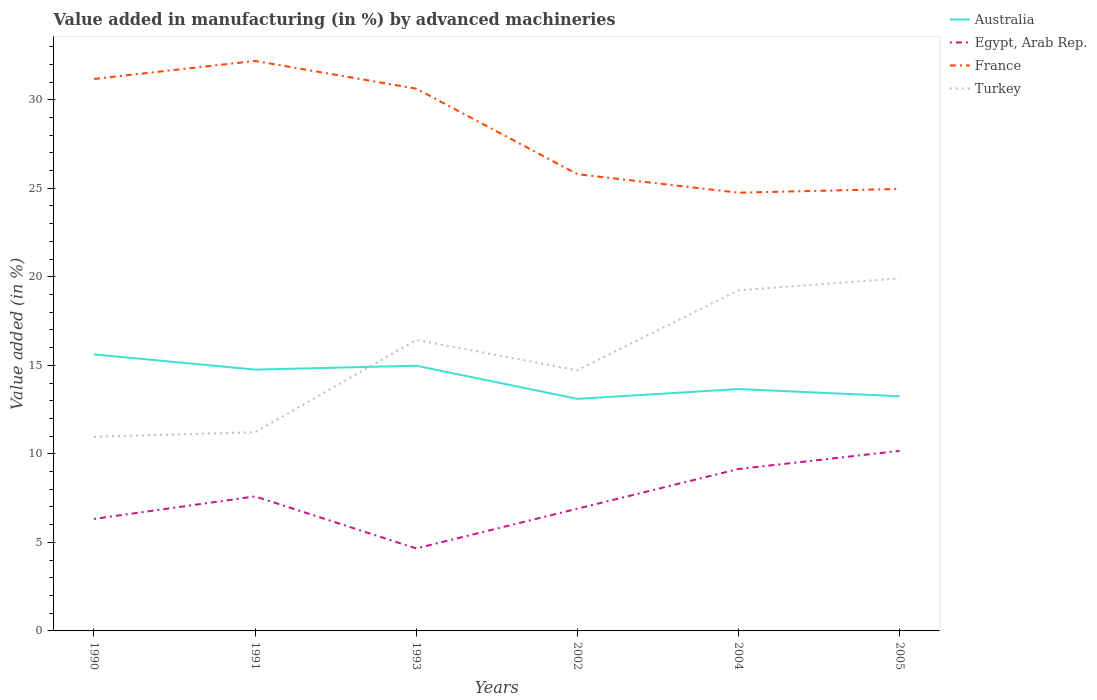Is the number of lines equal to the number of legend labels?
Offer a very short reply. Yes. Across all years, what is the maximum percentage of value added in manufacturing by advanced machineries in Egypt, Arab Rep.?
Offer a terse response. 4.66. In which year was the percentage of value added in manufacturing by advanced machineries in Egypt, Arab Rep. maximum?
Keep it short and to the point. 1993. What is the total percentage of value added in manufacturing by advanced machineries in Australia in the graph?
Keep it short and to the point. 0.41. What is the difference between the highest and the second highest percentage of value added in manufacturing by advanced machineries in Turkey?
Your answer should be very brief. 8.95. Are the values on the major ticks of Y-axis written in scientific E-notation?
Provide a succinct answer. No. Does the graph contain any zero values?
Your answer should be compact. No. Does the graph contain grids?
Keep it short and to the point. No. Where does the legend appear in the graph?
Provide a succinct answer. Top right. How many legend labels are there?
Provide a short and direct response. 4. What is the title of the graph?
Provide a short and direct response. Value added in manufacturing (in %) by advanced machineries. What is the label or title of the X-axis?
Ensure brevity in your answer.  Years. What is the label or title of the Y-axis?
Offer a terse response. Value added (in %). What is the Value added (in %) of Australia in 1990?
Your answer should be very brief. 15.62. What is the Value added (in %) of Egypt, Arab Rep. in 1990?
Ensure brevity in your answer.  6.33. What is the Value added (in %) of France in 1990?
Ensure brevity in your answer.  31.17. What is the Value added (in %) in Turkey in 1990?
Provide a short and direct response. 10.97. What is the Value added (in %) of Australia in 1991?
Provide a short and direct response. 14.76. What is the Value added (in %) in Egypt, Arab Rep. in 1991?
Provide a succinct answer. 7.6. What is the Value added (in %) of France in 1991?
Give a very brief answer. 32.19. What is the Value added (in %) in Turkey in 1991?
Your response must be concise. 11.22. What is the Value added (in %) of Australia in 1993?
Give a very brief answer. 14.98. What is the Value added (in %) of Egypt, Arab Rep. in 1993?
Offer a terse response. 4.66. What is the Value added (in %) in France in 1993?
Give a very brief answer. 30.63. What is the Value added (in %) of Turkey in 1993?
Keep it short and to the point. 16.44. What is the Value added (in %) of Australia in 2002?
Give a very brief answer. 13.11. What is the Value added (in %) in Egypt, Arab Rep. in 2002?
Your answer should be compact. 6.9. What is the Value added (in %) of France in 2002?
Your response must be concise. 25.8. What is the Value added (in %) of Turkey in 2002?
Your answer should be very brief. 14.72. What is the Value added (in %) in Australia in 2004?
Your response must be concise. 13.66. What is the Value added (in %) of Egypt, Arab Rep. in 2004?
Ensure brevity in your answer.  9.14. What is the Value added (in %) of France in 2004?
Your answer should be compact. 24.75. What is the Value added (in %) in Turkey in 2004?
Provide a short and direct response. 19.24. What is the Value added (in %) in Australia in 2005?
Your answer should be compact. 13.25. What is the Value added (in %) of Egypt, Arab Rep. in 2005?
Keep it short and to the point. 10.17. What is the Value added (in %) of France in 2005?
Your answer should be very brief. 24.96. What is the Value added (in %) of Turkey in 2005?
Your answer should be very brief. 19.91. Across all years, what is the maximum Value added (in %) in Australia?
Offer a terse response. 15.62. Across all years, what is the maximum Value added (in %) in Egypt, Arab Rep.?
Provide a short and direct response. 10.17. Across all years, what is the maximum Value added (in %) of France?
Offer a very short reply. 32.19. Across all years, what is the maximum Value added (in %) of Turkey?
Give a very brief answer. 19.91. Across all years, what is the minimum Value added (in %) of Australia?
Keep it short and to the point. 13.11. Across all years, what is the minimum Value added (in %) of Egypt, Arab Rep.?
Offer a terse response. 4.66. Across all years, what is the minimum Value added (in %) of France?
Your answer should be compact. 24.75. Across all years, what is the minimum Value added (in %) in Turkey?
Offer a very short reply. 10.97. What is the total Value added (in %) in Australia in the graph?
Keep it short and to the point. 85.37. What is the total Value added (in %) in Egypt, Arab Rep. in the graph?
Make the answer very short. 44.8. What is the total Value added (in %) of France in the graph?
Keep it short and to the point. 169.5. What is the total Value added (in %) of Turkey in the graph?
Ensure brevity in your answer.  92.49. What is the difference between the Value added (in %) in Australia in 1990 and that in 1991?
Keep it short and to the point. 0.86. What is the difference between the Value added (in %) in Egypt, Arab Rep. in 1990 and that in 1991?
Make the answer very short. -1.27. What is the difference between the Value added (in %) of France in 1990 and that in 1991?
Offer a very short reply. -1.02. What is the difference between the Value added (in %) of Turkey in 1990 and that in 1991?
Your response must be concise. -0.26. What is the difference between the Value added (in %) of Australia in 1990 and that in 1993?
Your answer should be very brief. 0.64. What is the difference between the Value added (in %) in Egypt, Arab Rep. in 1990 and that in 1993?
Give a very brief answer. 1.67. What is the difference between the Value added (in %) of France in 1990 and that in 1993?
Make the answer very short. 0.55. What is the difference between the Value added (in %) in Turkey in 1990 and that in 1993?
Make the answer very short. -5.47. What is the difference between the Value added (in %) in Australia in 1990 and that in 2002?
Keep it short and to the point. 2.51. What is the difference between the Value added (in %) of Egypt, Arab Rep. in 1990 and that in 2002?
Your answer should be compact. -0.58. What is the difference between the Value added (in %) of France in 1990 and that in 2002?
Provide a succinct answer. 5.38. What is the difference between the Value added (in %) in Turkey in 1990 and that in 2002?
Make the answer very short. -3.75. What is the difference between the Value added (in %) of Australia in 1990 and that in 2004?
Offer a very short reply. 1.96. What is the difference between the Value added (in %) in Egypt, Arab Rep. in 1990 and that in 2004?
Give a very brief answer. -2.82. What is the difference between the Value added (in %) of France in 1990 and that in 2004?
Offer a very short reply. 6.42. What is the difference between the Value added (in %) in Turkey in 1990 and that in 2004?
Your answer should be compact. -8.27. What is the difference between the Value added (in %) of Australia in 1990 and that in 2005?
Give a very brief answer. 2.36. What is the difference between the Value added (in %) in Egypt, Arab Rep. in 1990 and that in 2005?
Your answer should be compact. -3.84. What is the difference between the Value added (in %) of France in 1990 and that in 2005?
Ensure brevity in your answer.  6.21. What is the difference between the Value added (in %) of Turkey in 1990 and that in 2005?
Your response must be concise. -8.95. What is the difference between the Value added (in %) in Australia in 1991 and that in 1993?
Your answer should be very brief. -0.22. What is the difference between the Value added (in %) in Egypt, Arab Rep. in 1991 and that in 1993?
Give a very brief answer. 2.94. What is the difference between the Value added (in %) of France in 1991 and that in 1993?
Make the answer very short. 1.56. What is the difference between the Value added (in %) of Turkey in 1991 and that in 1993?
Make the answer very short. -5.21. What is the difference between the Value added (in %) of Australia in 1991 and that in 2002?
Your answer should be compact. 1.65. What is the difference between the Value added (in %) in Egypt, Arab Rep. in 1991 and that in 2002?
Give a very brief answer. 0.69. What is the difference between the Value added (in %) of France in 1991 and that in 2002?
Ensure brevity in your answer.  6.4. What is the difference between the Value added (in %) in Turkey in 1991 and that in 2002?
Keep it short and to the point. -3.5. What is the difference between the Value added (in %) of Australia in 1991 and that in 2004?
Your answer should be very brief. 1.1. What is the difference between the Value added (in %) of Egypt, Arab Rep. in 1991 and that in 2004?
Offer a terse response. -1.55. What is the difference between the Value added (in %) of France in 1991 and that in 2004?
Provide a succinct answer. 7.44. What is the difference between the Value added (in %) in Turkey in 1991 and that in 2004?
Your answer should be compact. -8.02. What is the difference between the Value added (in %) in Australia in 1991 and that in 2005?
Your answer should be compact. 1.51. What is the difference between the Value added (in %) in Egypt, Arab Rep. in 1991 and that in 2005?
Offer a terse response. -2.57. What is the difference between the Value added (in %) in France in 1991 and that in 2005?
Your answer should be very brief. 7.23. What is the difference between the Value added (in %) of Turkey in 1991 and that in 2005?
Make the answer very short. -8.69. What is the difference between the Value added (in %) in Australia in 1993 and that in 2002?
Offer a terse response. 1.87. What is the difference between the Value added (in %) of Egypt, Arab Rep. in 1993 and that in 2002?
Provide a succinct answer. -2.25. What is the difference between the Value added (in %) of France in 1993 and that in 2002?
Keep it short and to the point. 4.83. What is the difference between the Value added (in %) in Turkey in 1993 and that in 2002?
Your answer should be compact. 1.72. What is the difference between the Value added (in %) in Australia in 1993 and that in 2004?
Offer a very short reply. 1.32. What is the difference between the Value added (in %) of Egypt, Arab Rep. in 1993 and that in 2004?
Ensure brevity in your answer.  -4.49. What is the difference between the Value added (in %) of France in 1993 and that in 2004?
Offer a very short reply. 5.88. What is the difference between the Value added (in %) in Turkey in 1993 and that in 2004?
Make the answer very short. -2.8. What is the difference between the Value added (in %) of Australia in 1993 and that in 2005?
Offer a very short reply. 1.72. What is the difference between the Value added (in %) of Egypt, Arab Rep. in 1993 and that in 2005?
Offer a terse response. -5.51. What is the difference between the Value added (in %) of France in 1993 and that in 2005?
Your answer should be very brief. 5.66. What is the difference between the Value added (in %) in Turkey in 1993 and that in 2005?
Provide a succinct answer. -3.48. What is the difference between the Value added (in %) in Australia in 2002 and that in 2004?
Ensure brevity in your answer.  -0.55. What is the difference between the Value added (in %) of Egypt, Arab Rep. in 2002 and that in 2004?
Your answer should be very brief. -2.24. What is the difference between the Value added (in %) of France in 2002 and that in 2004?
Your response must be concise. 1.04. What is the difference between the Value added (in %) in Turkey in 2002 and that in 2004?
Keep it short and to the point. -4.52. What is the difference between the Value added (in %) in Australia in 2002 and that in 2005?
Make the answer very short. -0.15. What is the difference between the Value added (in %) of Egypt, Arab Rep. in 2002 and that in 2005?
Offer a very short reply. -3.26. What is the difference between the Value added (in %) in France in 2002 and that in 2005?
Your answer should be very brief. 0.83. What is the difference between the Value added (in %) of Turkey in 2002 and that in 2005?
Offer a very short reply. -5.19. What is the difference between the Value added (in %) in Australia in 2004 and that in 2005?
Your answer should be very brief. 0.41. What is the difference between the Value added (in %) of Egypt, Arab Rep. in 2004 and that in 2005?
Your response must be concise. -1.02. What is the difference between the Value added (in %) of France in 2004 and that in 2005?
Offer a terse response. -0.21. What is the difference between the Value added (in %) of Turkey in 2004 and that in 2005?
Your answer should be very brief. -0.67. What is the difference between the Value added (in %) in Australia in 1990 and the Value added (in %) in Egypt, Arab Rep. in 1991?
Your answer should be compact. 8.02. What is the difference between the Value added (in %) in Australia in 1990 and the Value added (in %) in France in 1991?
Your answer should be very brief. -16.57. What is the difference between the Value added (in %) in Australia in 1990 and the Value added (in %) in Turkey in 1991?
Your answer should be compact. 4.4. What is the difference between the Value added (in %) in Egypt, Arab Rep. in 1990 and the Value added (in %) in France in 1991?
Give a very brief answer. -25.86. What is the difference between the Value added (in %) of Egypt, Arab Rep. in 1990 and the Value added (in %) of Turkey in 1991?
Offer a very short reply. -4.9. What is the difference between the Value added (in %) of France in 1990 and the Value added (in %) of Turkey in 1991?
Provide a short and direct response. 19.95. What is the difference between the Value added (in %) of Australia in 1990 and the Value added (in %) of Egypt, Arab Rep. in 1993?
Your response must be concise. 10.96. What is the difference between the Value added (in %) in Australia in 1990 and the Value added (in %) in France in 1993?
Offer a very short reply. -15.01. What is the difference between the Value added (in %) in Australia in 1990 and the Value added (in %) in Turkey in 1993?
Provide a short and direct response. -0.82. What is the difference between the Value added (in %) of Egypt, Arab Rep. in 1990 and the Value added (in %) of France in 1993?
Ensure brevity in your answer.  -24.3. What is the difference between the Value added (in %) of Egypt, Arab Rep. in 1990 and the Value added (in %) of Turkey in 1993?
Your response must be concise. -10.11. What is the difference between the Value added (in %) in France in 1990 and the Value added (in %) in Turkey in 1993?
Keep it short and to the point. 14.74. What is the difference between the Value added (in %) of Australia in 1990 and the Value added (in %) of Egypt, Arab Rep. in 2002?
Give a very brief answer. 8.71. What is the difference between the Value added (in %) in Australia in 1990 and the Value added (in %) in France in 2002?
Make the answer very short. -10.18. What is the difference between the Value added (in %) in Australia in 1990 and the Value added (in %) in Turkey in 2002?
Offer a very short reply. 0.9. What is the difference between the Value added (in %) of Egypt, Arab Rep. in 1990 and the Value added (in %) of France in 2002?
Ensure brevity in your answer.  -19.47. What is the difference between the Value added (in %) in Egypt, Arab Rep. in 1990 and the Value added (in %) in Turkey in 2002?
Ensure brevity in your answer.  -8.39. What is the difference between the Value added (in %) in France in 1990 and the Value added (in %) in Turkey in 2002?
Provide a short and direct response. 16.45. What is the difference between the Value added (in %) of Australia in 1990 and the Value added (in %) of Egypt, Arab Rep. in 2004?
Provide a succinct answer. 6.47. What is the difference between the Value added (in %) in Australia in 1990 and the Value added (in %) in France in 2004?
Your answer should be very brief. -9.13. What is the difference between the Value added (in %) of Australia in 1990 and the Value added (in %) of Turkey in 2004?
Make the answer very short. -3.62. What is the difference between the Value added (in %) of Egypt, Arab Rep. in 1990 and the Value added (in %) of France in 2004?
Make the answer very short. -18.42. What is the difference between the Value added (in %) of Egypt, Arab Rep. in 1990 and the Value added (in %) of Turkey in 2004?
Your answer should be very brief. -12.91. What is the difference between the Value added (in %) in France in 1990 and the Value added (in %) in Turkey in 2004?
Your response must be concise. 11.94. What is the difference between the Value added (in %) in Australia in 1990 and the Value added (in %) in Egypt, Arab Rep. in 2005?
Your answer should be compact. 5.45. What is the difference between the Value added (in %) of Australia in 1990 and the Value added (in %) of France in 2005?
Your answer should be very brief. -9.35. What is the difference between the Value added (in %) of Australia in 1990 and the Value added (in %) of Turkey in 2005?
Offer a terse response. -4.29. What is the difference between the Value added (in %) in Egypt, Arab Rep. in 1990 and the Value added (in %) in France in 2005?
Your answer should be very brief. -18.64. What is the difference between the Value added (in %) of Egypt, Arab Rep. in 1990 and the Value added (in %) of Turkey in 2005?
Ensure brevity in your answer.  -13.59. What is the difference between the Value added (in %) of France in 1990 and the Value added (in %) of Turkey in 2005?
Provide a short and direct response. 11.26. What is the difference between the Value added (in %) of Australia in 1991 and the Value added (in %) of Egypt, Arab Rep. in 1993?
Provide a short and direct response. 10.1. What is the difference between the Value added (in %) in Australia in 1991 and the Value added (in %) in France in 1993?
Your answer should be compact. -15.87. What is the difference between the Value added (in %) of Australia in 1991 and the Value added (in %) of Turkey in 1993?
Ensure brevity in your answer.  -1.68. What is the difference between the Value added (in %) of Egypt, Arab Rep. in 1991 and the Value added (in %) of France in 1993?
Keep it short and to the point. -23.03. What is the difference between the Value added (in %) in Egypt, Arab Rep. in 1991 and the Value added (in %) in Turkey in 1993?
Provide a short and direct response. -8.84. What is the difference between the Value added (in %) in France in 1991 and the Value added (in %) in Turkey in 1993?
Your answer should be compact. 15.75. What is the difference between the Value added (in %) of Australia in 1991 and the Value added (in %) of Egypt, Arab Rep. in 2002?
Make the answer very short. 7.85. What is the difference between the Value added (in %) of Australia in 1991 and the Value added (in %) of France in 2002?
Your response must be concise. -11.04. What is the difference between the Value added (in %) of Australia in 1991 and the Value added (in %) of Turkey in 2002?
Offer a terse response. 0.04. What is the difference between the Value added (in %) of Egypt, Arab Rep. in 1991 and the Value added (in %) of France in 2002?
Provide a short and direct response. -18.2. What is the difference between the Value added (in %) of Egypt, Arab Rep. in 1991 and the Value added (in %) of Turkey in 2002?
Provide a succinct answer. -7.12. What is the difference between the Value added (in %) of France in 1991 and the Value added (in %) of Turkey in 2002?
Offer a very short reply. 17.47. What is the difference between the Value added (in %) in Australia in 1991 and the Value added (in %) in Egypt, Arab Rep. in 2004?
Keep it short and to the point. 5.61. What is the difference between the Value added (in %) in Australia in 1991 and the Value added (in %) in France in 2004?
Give a very brief answer. -9.99. What is the difference between the Value added (in %) of Australia in 1991 and the Value added (in %) of Turkey in 2004?
Provide a short and direct response. -4.48. What is the difference between the Value added (in %) of Egypt, Arab Rep. in 1991 and the Value added (in %) of France in 2004?
Make the answer very short. -17.15. What is the difference between the Value added (in %) in Egypt, Arab Rep. in 1991 and the Value added (in %) in Turkey in 2004?
Offer a very short reply. -11.64. What is the difference between the Value added (in %) in France in 1991 and the Value added (in %) in Turkey in 2004?
Keep it short and to the point. 12.95. What is the difference between the Value added (in %) in Australia in 1991 and the Value added (in %) in Egypt, Arab Rep. in 2005?
Provide a short and direct response. 4.59. What is the difference between the Value added (in %) in Australia in 1991 and the Value added (in %) in France in 2005?
Your response must be concise. -10.2. What is the difference between the Value added (in %) of Australia in 1991 and the Value added (in %) of Turkey in 2005?
Offer a very short reply. -5.15. What is the difference between the Value added (in %) in Egypt, Arab Rep. in 1991 and the Value added (in %) in France in 2005?
Your answer should be very brief. -17.37. What is the difference between the Value added (in %) of Egypt, Arab Rep. in 1991 and the Value added (in %) of Turkey in 2005?
Provide a short and direct response. -12.32. What is the difference between the Value added (in %) in France in 1991 and the Value added (in %) in Turkey in 2005?
Ensure brevity in your answer.  12.28. What is the difference between the Value added (in %) of Australia in 1993 and the Value added (in %) of Egypt, Arab Rep. in 2002?
Provide a succinct answer. 8.07. What is the difference between the Value added (in %) in Australia in 1993 and the Value added (in %) in France in 2002?
Ensure brevity in your answer.  -10.82. What is the difference between the Value added (in %) in Australia in 1993 and the Value added (in %) in Turkey in 2002?
Make the answer very short. 0.26. What is the difference between the Value added (in %) in Egypt, Arab Rep. in 1993 and the Value added (in %) in France in 2002?
Provide a short and direct response. -21.14. What is the difference between the Value added (in %) in Egypt, Arab Rep. in 1993 and the Value added (in %) in Turkey in 2002?
Keep it short and to the point. -10.06. What is the difference between the Value added (in %) in France in 1993 and the Value added (in %) in Turkey in 2002?
Offer a terse response. 15.91. What is the difference between the Value added (in %) of Australia in 1993 and the Value added (in %) of Egypt, Arab Rep. in 2004?
Offer a terse response. 5.83. What is the difference between the Value added (in %) in Australia in 1993 and the Value added (in %) in France in 2004?
Give a very brief answer. -9.77. What is the difference between the Value added (in %) of Australia in 1993 and the Value added (in %) of Turkey in 2004?
Offer a terse response. -4.26. What is the difference between the Value added (in %) of Egypt, Arab Rep. in 1993 and the Value added (in %) of France in 2004?
Offer a very short reply. -20.09. What is the difference between the Value added (in %) of Egypt, Arab Rep. in 1993 and the Value added (in %) of Turkey in 2004?
Give a very brief answer. -14.58. What is the difference between the Value added (in %) in France in 1993 and the Value added (in %) in Turkey in 2004?
Provide a short and direct response. 11.39. What is the difference between the Value added (in %) in Australia in 1993 and the Value added (in %) in Egypt, Arab Rep. in 2005?
Provide a short and direct response. 4.81. What is the difference between the Value added (in %) in Australia in 1993 and the Value added (in %) in France in 2005?
Keep it short and to the point. -9.99. What is the difference between the Value added (in %) of Australia in 1993 and the Value added (in %) of Turkey in 2005?
Your answer should be compact. -4.94. What is the difference between the Value added (in %) of Egypt, Arab Rep. in 1993 and the Value added (in %) of France in 2005?
Provide a short and direct response. -20.31. What is the difference between the Value added (in %) in Egypt, Arab Rep. in 1993 and the Value added (in %) in Turkey in 2005?
Provide a succinct answer. -15.25. What is the difference between the Value added (in %) of France in 1993 and the Value added (in %) of Turkey in 2005?
Your answer should be very brief. 10.71. What is the difference between the Value added (in %) of Australia in 2002 and the Value added (in %) of Egypt, Arab Rep. in 2004?
Give a very brief answer. 3.96. What is the difference between the Value added (in %) in Australia in 2002 and the Value added (in %) in France in 2004?
Your response must be concise. -11.64. What is the difference between the Value added (in %) of Australia in 2002 and the Value added (in %) of Turkey in 2004?
Your answer should be very brief. -6.13. What is the difference between the Value added (in %) of Egypt, Arab Rep. in 2002 and the Value added (in %) of France in 2004?
Your answer should be compact. -17.85. What is the difference between the Value added (in %) of Egypt, Arab Rep. in 2002 and the Value added (in %) of Turkey in 2004?
Your answer should be compact. -12.33. What is the difference between the Value added (in %) in France in 2002 and the Value added (in %) in Turkey in 2004?
Give a very brief answer. 6.56. What is the difference between the Value added (in %) in Australia in 2002 and the Value added (in %) in Egypt, Arab Rep. in 2005?
Provide a succinct answer. 2.94. What is the difference between the Value added (in %) of Australia in 2002 and the Value added (in %) of France in 2005?
Offer a terse response. -11.86. What is the difference between the Value added (in %) in Australia in 2002 and the Value added (in %) in Turkey in 2005?
Provide a short and direct response. -6.81. What is the difference between the Value added (in %) of Egypt, Arab Rep. in 2002 and the Value added (in %) of France in 2005?
Make the answer very short. -18.06. What is the difference between the Value added (in %) of Egypt, Arab Rep. in 2002 and the Value added (in %) of Turkey in 2005?
Ensure brevity in your answer.  -13.01. What is the difference between the Value added (in %) of France in 2002 and the Value added (in %) of Turkey in 2005?
Ensure brevity in your answer.  5.88. What is the difference between the Value added (in %) of Australia in 2004 and the Value added (in %) of Egypt, Arab Rep. in 2005?
Your answer should be compact. 3.49. What is the difference between the Value added (in %) in Australia in 2004 and the Value added (in %) in France in 2005?
Your response must be concise. -11.3. What is the difference between the Value added (in %) in Australia in 2004 and the Value added (in %) in Turkey in 2005?
Keep it short and to the point. -6.25. What is the difference between the Value added (in %) of Egypt, Arab Rep. in 2004 and the Value added (in %) of France in 2005?
Ensure brevity in your answer.  -15.82. What is the difference between the Value added (in %) of Egypt, Arab Rep. in 2004 and the Value added (in %) of Turkey in 2005?
Provide a succinct answer. -10.77. What is the difference between the Value added (in %) in France in 2004 and the Value added (in %) in Turkey in 2005?
Your answer should be very brief. 4.84. What is the average Value added (in %) of Australia per year?
Ensure brevity in your answer.  14.23. What is the average Value added (in %) in Egypt, Arab Rep. per year?
Ensure brevity in your answer.  7.47. What is the average Value added (in %) in France per year?
Make the answer very short. 28.25. What is the average Value added (in %) of Turkey per year?
Your answer should be compact. 15.42. In the year 1990, what is the difference between the Value added (in %) of Australia and Value added (in %) of Egypt, Arab Rep.?
Ensure brevity in your answer.  9.29. In the year 1990, what is the difference between the Value added (in %) of Australia and Value added (in %) of France?
Make the answer very short. -15.56. In the year 1990, what is the difference between the Value added (in %) in Australia and Value added (in %) in Turkey?
Your answer should be very brief. 4.65. In the year 1990, what is the difference between the Value added (in %) in Egypt, Arab Rep. and Value added (in %) in France?
Your response must be concise. -24.85. In the year 1990, what is the difference between the Value added (in %) of Egypt, Arab Rep. and Value added (in %) of Turkey?
Your answer should be compact. -4.64. In the year 1990, what is the difference between the Value added (in %) in France and Value added (in %) in Turkey?
Your answer should be compact. 20.21. In the year 1991, what is the difference between the Value added (in %) of Australia and Value added (in %) of Egypt, Arab Rep.?
Ensure brevity in your answer.  7.16. In the year 1991, what is the difference between the Value added (in %) of Australia and Value added (in %) of France?
Your answer should be very brief. -17.43. In the year 1991, what is the difference between the Value added (in %) in Australia and Value added (in %) in Turkey?
Offer a very short reply. 3.54. In the year 1991, what is the difference between the Value added (in %) in Egypt, Arab Rep. and Value added (in %) in France?
Your answer should be compact. -24.59. In the year 1991, what is the difference between the Value added (in %) in Egypt, Arab Rep. and Value added (in %) in Turkey?
Your answer should be compact. -3.63. In the year 1991, what is the difference between the Value added (in %) in France and Value added (in %) in Turkey?
Offer a terse response. 20.97. In the year 1993, what is the difference between the Value added (in %) of Australia and Value added (in %) of Egypt, Arab Rep.?
Offer a terse response. 10.32. In the year 1993, what is the difference between the Value added (in %) of Australia and Value added (in %) of France?
Your answer should be very brief. -15.65. In the year 1993, what is the difference between the Value added (in %) of Australia and Value added (in %) of Turkey?
Your response must be concise. -1.46. In the year 1993, what is the difference between the Value added (in %) in Egypt, Arab Rep. and Value added (in %) in France?
Your response must be concise. -25.97. In the year 1993, what is the difference between the Value added (in %) of Egypt, Arab Rep. and Value added (in %) of Turkey?
Offer a very short reply. -11.78. In the year 1993, what is the difference between the Value added (in %) of France and Value added (in %) of Turkey?
Offer a very short reply. 14.19. In the year 2002, what is the difference between the Value added (in %) of Australia and Value added (in %) of Egypt, Arab Rep.?
Offer a very short reply. 6.2. In the year 2002, what is the difference between the Value added (in %) of Australia and Value added (in %) of France?
Your answer should be compact. -12.69. In the year 2002, what is the difference between the Value added (in %) of Australia and Value added (in %) of Turkey?
Your answer should be very brief. -1.61. In the year 2002, what is the difference between the Value added (in %) of Egypt, Arab Rep. and Value added (in %) of France?
Make the answer very short. -18.89. In the year 2002, what is the difference between the Value added (in %) in Egypt, Arab Rep. and Value added (in %) in Turkey?
Offer a terse response. -7.82. In the year 2002, what is the difference between the Value added (in %) in France and Value added (in %) in Turkey?
Your answer should be very brief. 11.08. In the year 2004, what is the difference between the Value added (in %) of Australia and Value added (in %) of Egypt, Arab Rep.?
Your answer should be compact. 4.52. In the year 2004, what is the difference between the Value added (in %) of Australia and Value added (in %) of France?
Your answer should be very brief. -11.09. In the year 2004, what is the difference between the Value added (in %) in Australia and Value added (in %) in Turkey?
Your answer should be compact. -5.58. In the year 2004, what is the difference between the Value added (in %) of Egypt, Arab Rep. and Value added (in %) of France?
Give a very brief answer. -15.61. In the year 2004, what is the difference between the Value added (in %) in Egypt, Arab Rep. and Value added (in %) in Turkey?
Offer a very short reply. -10.09. In the year 2004, what is the difference between the Value added (in %) in France and Value added (in %) in Turkey?
Provide a short and direct response. 5.51. In the year 2005, what is the difference between the Value added (in %) of Australia and Value added (in %) of Egypt, Arab Rep.?
Offer a very short reply. 3.08. In the year 2005, what is the difference between the Value added (in %) in Australia and Value added (in %) in France?
Your answer should be very brief. -11.71. In the year 2005, what is the difference between the Value added (in %) of Australia and Value added (in %) of Turkey?
Ensure brevity in your answer.  -6.66. In the year 2005, what is the difference between the Value added (in %) in Egypt, Arab Rep. and Value added (in %) in France?
Your answer should be very brief. -14.8. In the year 2005, what is the difference between the Value added (in %) of Egypt, Arab Rep. and Value added (in %) of Turkey?
Give a very brief answer. -9.74. In the year 2005, what is the difference between the Value added (in %) in France and Value added (in %) in Turkey?
Ensure brevity in your answer.  5.05. What is the ratio of the Value added (in %) in Australia in 1990 to that in 1991?
Keep it short and to the point. 1.06. What is the ratio of the Value added (in %) of Egypt, Arab Rep. in 1990 to that in 1991?
Provide a succinct answer. 0.83. What is the ratio of the Value added (in %) of France in 1990 to that in 1991?
Keep it short and to the point. 0.97. What is the ratio of the Value added (in %) in Turkey in 1990 to that in 1991?
Provide a short and direct response. 0.98. What is the ratio of the Value added (in %) of Australia in 1990 to that in 1993?
Keep it short and to the point. 1.04. What is the ratio of the Value added (in %) in Egypt, Arab Rep. in 1990 to that in 1993?
Give a very brief answer. 1.36. What is the ratio of the Value added (in %) in France in 1990 to that in 1993?
Provide a short and direct response. 1.02. What is the ratio of the Value added (in %) in Turkey in 1990 to that in 1993?
Your answer should be very brief. 0.67. What is the ratio of the Value added (in %) in Australia in 1990 to that in 2002?
Your answer should be compact. 1.19. What is the ratio of the Value added (in %) in Egypt, Arab Rep. in 1990 to that in 2002?
Keep it short and to the point. 0.92. What is the ratio of the Value added (in %) of France in 1990 to that in 2002?
Give a very brief answer. 1.21. What is the ratio of the Value added (in %) in Turkey in 1990 to that in 2002?
Your answer should be compact. 0.74. What is the ratio of the Value added (in %) in Australia in 1990 to that in 2004?
Provide a short and direct response. 1.14. What is the ratio of the Value added (in %) of Egypt, Arab Rep. in 1990 to that in 2004?
Your answer should be very brief. 0.69. What is the ratio of the Value added (in %) in France in 1990 to that in 2004?
Your response must be concise. 1.26. What is the ratio of the Value added (in %) in Turkey in 1990 to that in 2004?
Give a very brief answer. 0.57. What is the ratio of the Value added (in %) in Australia in 1990 to that in 2005?
Ensure brevity in your answer.  1.18. What is the ratio of the Value added (in %) of Egypt, Arab Rep. in 1990 to that in 2005?
Offer a terse response. 0.62. What is the ratio of the Value added (in %) of France in 1990 to that in 2005?
Keep it short and to the point. 1.25. What is the ratio of the Value added (in %) of Turkey in 1990 to that in 2005?
Your response must be concise. 0.55. What is the ratio of the Value added (in %) in Australia in 1991 to that in 1993?
Your answer should be compact. 0.99. What is the ratio of the Value added (in %) in Egypt, Arab Rep. in 1991 to that in 1993?
Offer a terse response. 1.63. What is the ratio of the Value added (in %) in France in 1991 to that in 1993?
Your answer should be very brief. 1.05. What is the ratio of the Value added (in %) of Turkey in 1991 to that in 1993?
Your answer should be very brief. 0.68. What is the ratio of the Value added (in %) in Australia in 1991 to that in 2002?
Provide a short and direct response. 1.13. What is the ratio of the Value added (in %) in Egypt, Arab Rep. in 1991 to that in 2002?
Offer a terse response. 1.1. What is the ratio of the Value added (in %) of France in 1991 to that in 2002?
Ensure brevity in your answer.  1.25. What is the ratio of the Value added (in %) in Turkey in 1991 to that in 2002?
Keep it short and to the point. 0.76. What is the ratio of the Value added (in %) of Australia in 1991 to that in 2004?
Offer a terse response. 1.08. What is the ratio of the Value added (in %) of Egypt, Arab Rep. in 1991 to that in 2004?
Keep it short and to the point. 0.83. What is the ratio of the Value added (in %) in France in 1991 to that in 2004?
Your answer should be compact. 1.3. What is the ratio of the Value added (in %) in Turkey in 1991 to that in 2004?
Provide a succinct answer. 0.58. What is the ratio of the Value added (in %) in Australia in 1991 to that in 2005?
Make the answer very short. 1.11. What is the ratio of the Value added (in %) of Egypt, Arab Rep. in 1991 to that in 2005?
Provide a short and direct response. 0.75. What is the ratio of the Value added (in %) of France in 1991 to that in 2005?
Provide a short and direct response. 1.29. What is the ratio of the Value added (in %) in Turkey in 1991 to that in 2005?
Your answer should be compact. 0.56. What is the ratio of the Value added (in %) in Australia in 1993 to that in 2002?
Offer a very short reply. 1.14. What is the ratio of the Value added (in %) in Egypt, Arab Rep. in 1993 to that in 2002?
Make the answer very short. 0.67. What is the ratio of the Value added (in %) in France in 1993 to that in 2002?
Give a very brief answer. 1.19. What is the ratio of the Value added (in %) in Turkey in 1993 to that in 2002?
Keep it short and to the point. 1.12. What is the ratio of the Value added (in %) in Australia in 1993 to that in 2004?
Give a very brief answer. 1.1. What is the ratio of the Value added (in %) in Egypt, Arab Rep. in 1993 to that in 2004?
Offer a very short reply. 0.51. What is the ratio of the Value added (in %) of France in 1993 to that in 2004?
Give a very brief answer. 1.24. What is the ratio of the Value added (in %) in Turkey in 1993 to that in 2004?
Offer a very short reply. 0.85. What is the ratio of the Value added (in %) of Australia in 1993 to that in 2005?
Your answer should be very brief. 1.13. What is the ratio of the Value added (in %) in Egypt, Arab Rep. in 1993 to that in 2005?
Your answer should be compact. 0.46. What is the ratio of the Value added (in %) in France in 1993 to that in 2005?
Offer a very short reply. 1.23. What is the ratio of the Value added (in %) of Turkey in 1993 to that in 2005?
Offer a very short reply. 0.83. What is the ratio of the Value added (in %) of Australia in 2002 to that in 2004?
Give a very brief answer. 0.96. What is the ratio of the Value added (in %) of Egypt, Arab Rep. in 2002 to that in 2004?
Offer a very short reply. 0.76. What is the ratio of the Value added (in %) in France in 2002 to that in 2004?
Give a very brief answer. 1.04. What is the ratio of the Value added (in %) of Turkey in 2002 to that in 2004?
Provide a short and direct response. 0.77. What is the ratio of the Value added (in %) in Australia in 2002 to that in 2005?
Offer a very short reply. 0.99. What is the ratio of the Value added (in %) in Egypt, Arab Rep. in 2002 to that in 2005?
Your answer should be very brief. 0.68. What is the ratio of the Value added (in %) in Turkey in 2002 to that in 2005?
Your response must be concise. 0.74. What is the ratio of the Value added (in %) in Australia in 2004 to that in 2005?
Your response must be concise. 1.03. What is the ratio of the Value added (in %) of Egypt, Arab Rep. in 2004 to that in 2005?
Your answer should be very brief. 0.9. What is the ratio of the Value added (in %) in France in 2004 to that in 2005?
Your answer should be compact. 0.99. What is the ratio of the Value added (in %) of Turkey in 2004 to that in 2005?
Offer a very short reply. 0.97. What is the difference between the highest and the second highest Value added (in %) of Australia?
Give a very brief answer. 0.64. What is the difference between the highest and the second highest Value added (in %) in Egypt, Arab Rep.?
Make the answer very short. 1.02. What is the difference between the highest and the second highest Value added (in %) in France?
Keep it short and to the point. 1.02. What is the difference between the highest and the second highest Value added (in %) in Turkey?
Your answer should be very brief. 0.67. What is the difference between the highest and the lowest Value added (in %) of Australia?
Your response must be concise. 2.51. What is the difference between the highest and the lowest Value added (in %) in Egypt, Arab Rep.?
Your response must be concise. 5.51. What is the difference between the highest and the lowest Value added (in %) of France?
Ensure brevity in your answer.  7.44. What is the difference between the highest and the lowest Value added (in %) of Turkey?
Give a very brief answer. 8.95. 